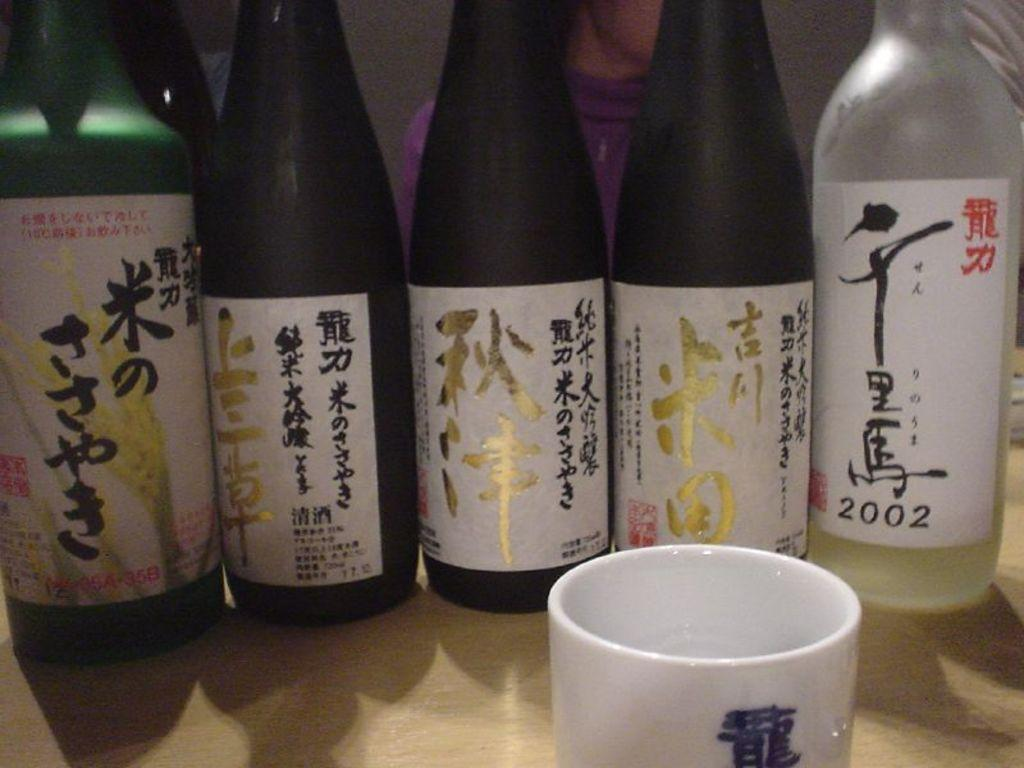<image>
Present a compact description of the photo's key features. Five bottles with Chinese characters on them sit in a line, one of the dates reads 2002. 